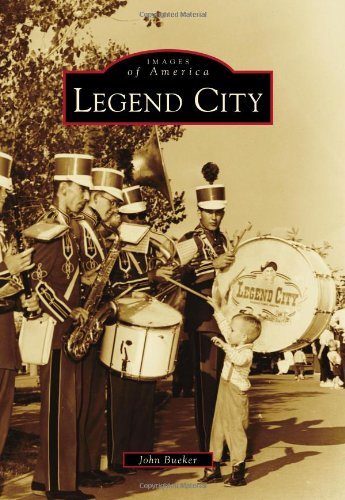Is this book related to Travel? Yes, the book is related to travel as it invites readers on a visual and historical journey through Legend City, facilitating a deeper understanding of its evolution and significance to American entertainment landscapes. 